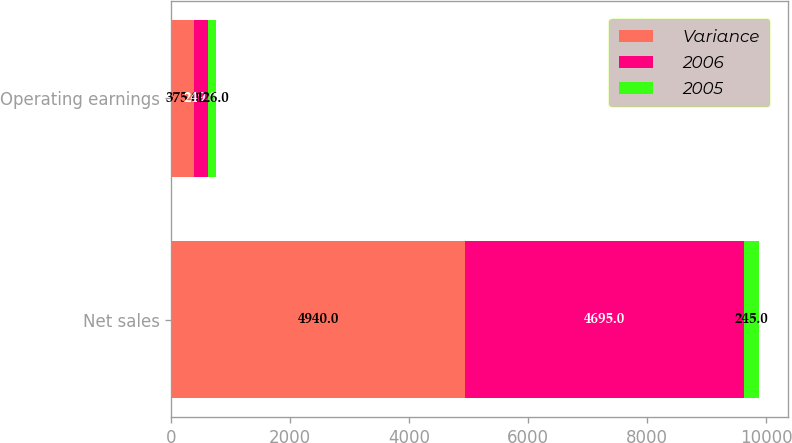Convert chart to OTSL. <chart><loc_0><loc_0><loc_500><loc_500><stacked_bar_chart><ecel><fcel>Net sales<fcel>Operating earnings<nl><fcel>Variance<fcel>4940<fcel>375<nl><fcel>2006<fcel>4695<fcel>249<nl><fcel>2005<fcel>245<fcel>126<nl></chart> 